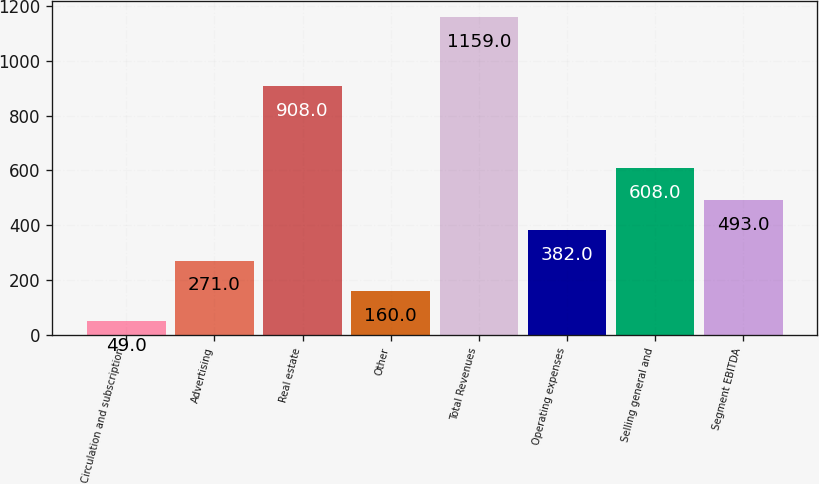<chart> <loc_0><loc_0><loc_500><loc_500><bar_chart><fcel>Circulation and subscription<fcel>Advertising<fcel>Real estate<fcel>Other<fcel>Total Revenues<fcel>Operating expenses<fcel>Selling general and<fcel>Segment EBITDA<nl><fcel>49<fcel>271<fcel>908<fcel>160<fcel>1159<fcel>382<fcel>608<fcel>493<nl></chart> 